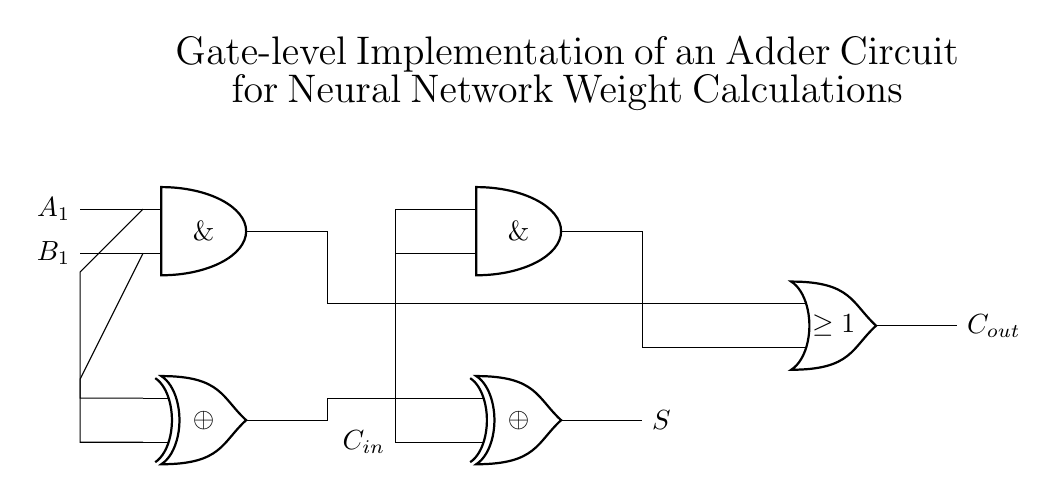What type of circuit is shown? The circuit is an adder circuit, specifically designed using logic gates to perform binary addition. The half adder structure, consisting of XOR and AND gates, is a fundamental component of addition in digital circuits.
Answer: Adder circuit How many inputs does the first half adder have? The first half adder, indicated in the circuit, has two inputs: A1 and B1. Each of these inputs represents a binary digit, which the half adder processes to generate a sum and carry output.
Answer: Two inputs What do the outputs represent? The outputs of the circuit, labeled S and C out, represent the sum and carry from the addition operation, respectively. S is the result of the addition, while C out indicates whether there was an overflow (carry) to a higher bit.
Answer: Sum and carry Which gates are used in the half adder? The gates used in the half adder are XOR and AND gates. The XOR gate provides the sum output, and the AND gate provides the carry output, reflecting the standard definition of a half adder in digital logic design.
Answer: XOR and AND gates How is the carry-in connected in this circuit? The carry-in (C in) is connected to the second half adder and is used as an additional input, which allows the circuit to handle the addition of three binary inputs: A1, B1, and the carry-in from a previous addition.
Answer: Connected to the second half adder What is the purpose of the OR gate in this circuit? The OR gate combines the outputs of the two AND gates to determine if there is a carry-out. The function of this gate is to check if either of the half adders produces a carry, thus facilitating multi-bit binary addition.
Answer: Determine carry-out 